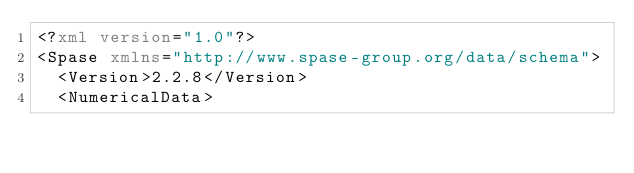Convert code to text. <code><loc_0><loc_0><loc_500><loc_500><_XML_><?xml version="1.0"?>
<Spase xmlns="http://www.spase-group.org/data/schema">
  <Version>2.2.8</Version>
  <NumericalData></code> 